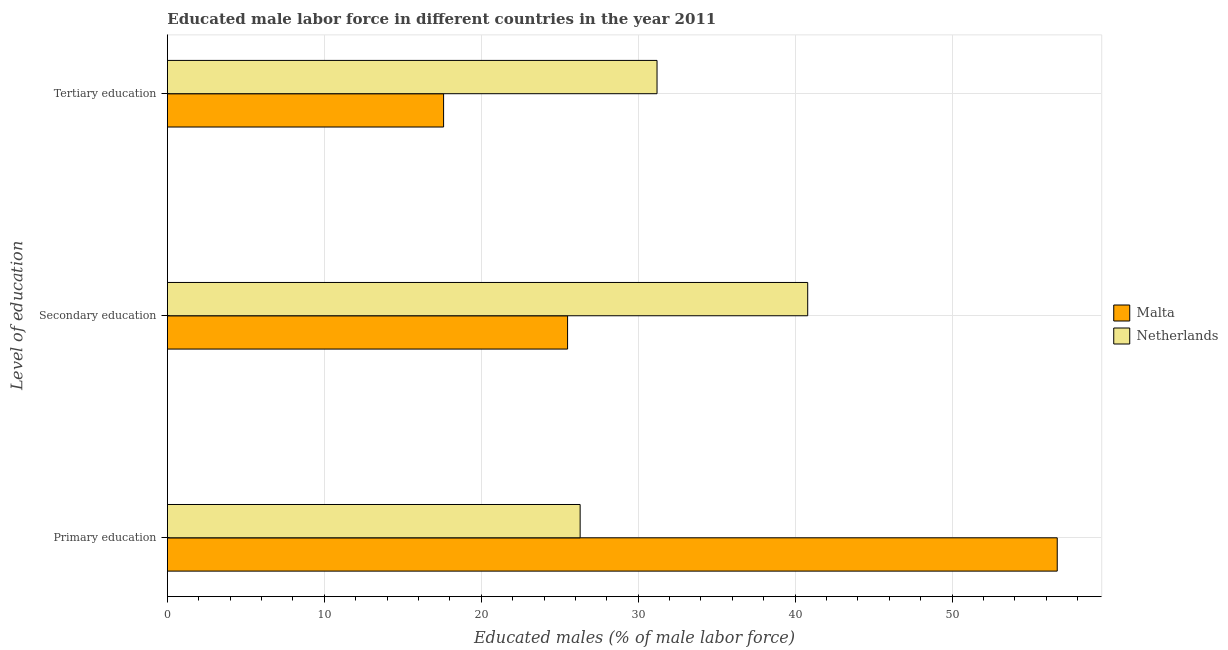Are the number of bars on each tick of the Y-axis equal?
Provide a short and direct response. Yes. How many bars are there on the 3rd tick from the top?
Keep it short and to the point. 2. How many bars are there on the 1st tick from the bottom?
Your answer should be compact. 2. What is the label of the 1st group of bars from the top?
Your answer should be very brief. Tertiary education. What is the percentage of male labor force who received tertiary education in Netherlands?
Give a very brief answer. 31.2. Across all countries, what is the maximum percentage of male labor force who received primary education?
Your answer should be compact. 56.7. Across all countries, what is the minimum percentage of male labor force who received tertiary education?
Provide a short and direct response. 17.6. In which country was the percentage of male labor force who received tertiary education maximum?
Ensure brevity in your answer.  Netherlands. In which country was the percentage of male labor force who received tertiary education minimum?
Your response must be concise. Malta. What is the total percentage of male labor force who received secondary education in the graph?
Offer a terse response. 66.3. What is the difference between the percentage of male labor force who received secondary education in Netherlands and that in Malta?
Keep it short and to the point. 15.3. What is the difference between the percentage of male labor force who received tertiary education in Netherlands and the percentage of male labor force who received secondary education in Malta?
Offer a very short reply. 5.7. What is the average percentage of male labor force who received primary education per country?
Keep it short and to the point. 41.5. What is the difference between the percentage of male labor force who received tertiary education and percentage of male labor force who received secondary education in Netherlands?
Ensure brevity in your answer.  -9.6. What is the ratio of the percentage of male labor force who received tertiary education in Malta to that in Netherlands?
Make the answer very short. 0.56. Is the difference between the percentage of male labor force who received tertiary education in Netherlands and Malta greater than the difference between the percentage of male labor force who received secondary education in Netherlands and Malta?
Make the answer very short. No. What is the difference between the highest and the second highest percentage of male labor force who received secondary education?
Provide a short and direct response. 15.3. What is the difference between the highest and the lowest percentage of male labor force who received tertiary education?
Give a very brief answer. 13.6. In how many countries, is the percentage of male labor force who received secondary education greater than the average percentage of male labor force who received secondary education taken over all countries?
Your response must be concise. 1. What does the 2nd bar from the top in Tertiary education represents?
Make the answer very short. Malta. What does the 1st bar from the bottom in Primary education represents?
Your answer should be very brief. Malta. Is it the case that in every country, the sum of the percentage of male labor force who received primary education and percentage of male labor force who received secondary education is greater than the percentage of male labor force who received tertiary education?
Give a very brief answer. Yes. How many bars are there?
Offer a terse response. 6. Are all the bars in the graph horizontal?
Offer a terse response. Yes. How many countries are there in the graph?
Provide a short and direct response. 2. Does the graph contain grids?
Your answer should be very brief. Yes. How are the legend labels stacked?
Your response must be concise. Vertical. What is the title of the graph?
Offer a terse response. Educated male labor force in different countries in the year 2011. What is the label or title of the X-axis?
Offer a very short reply. Educated males (% of male labor force). What is the label or title of the Y-axis?
Your answer should be very brief. Level of education. What is the Educated males (% of male labor force) of Malta in Primary education?
Offer a terse response. 56.7. What is the Educated males (% of male labor force) of Netherlands in Primary education?
Ensure brevity in your answer.  26.3. What is the Educated males (% of male labor force) of Malta in Secondary education?
Make the answer very short. 25.5. What is the Educated males (% of male labor force) in Netherlands in Secondary education?
Your answer should be compact. 40.8. What is the Educated males (% of male labor force) in Malta in Tertiary education?
Your answer should be very brief. 17.6. What is the Educated males (% of male labor force) of Netherlands in Tertiary education?
Give a very brief answer. 31.2. Across all Level of education, what is the maximum Educated males (% of male labor force) of Malta?
Keep it short and to the point. 56.7. Across all Level of education, what is the maximum Educated males (% of male labor force) in Netherlands?
Ensure brevity in your answer.  40.8. Across all Level of education, what is the minimum Educated males (% of male labor force) in Malta?
Offer a very short reply. 17.6. Across all Level of education, what is the minimum Educated males (% of male labor force) in Netherlands?
Your answer should be compact. 26.3. What is the total Educated males (% of male labor force) in Malta in the graph?
Offer a terse response. 99.8. What is the total Educated males (% of male labor force) of Netherlands in the graph?
Provide a short and direct response. 98.3. What is the difference between the Educated males (% of male labor force) of Malta in Primary education and that in Secondary education?
Offer a terse response. 31.2. What is the difference between the Educated males (% of male labor force) in Netherlands in Primary education and that in Secondary education?
Make the answer very short. -14.5. What is the difference between the Educated males (% of male labor force) of Malta in Primary education and that in Tertiary education?
Your answer should be compact. 39.1. What is the difference between the Educated males (% of male labor force) in Netherlands in Primary education and that in Tertiary education?
Your answer should be compact. -4.9. What is the difference between the Educated males (% of male labor force) in Malta in Secondary education and that in Tertiary education?
Your answer should be compact. 7.9. What is the difference between the Educated males (% of male labor force) in Netherlands in Secondary education and that in Tertiary education?
Provide a succinct answer. 9.6. What is the average Educated males (% of male labor force) of Malta per Level of education?
Ensure brevity in your answer.  33.27. What is the average Educated males (% of male labor force) in Netherlands per Level of education?
Keep it short and to the point. 32.77. What is the difference between the Educated males (% of male labor force) in Malta and Educated males (% of male labor force) in Netherlands in Primary education?
Your answer should be compact. 30.4. What is the difference between the Educated males (% of male labor force) in Malta and Educated males (% of male labor force) in Netherlands in Secondary education?
Offer a very short reply. -15.3. What is the difference between the Educated males (% of male labor force) in Malta and Educated males (% of male labor force) in Netherlands in Tertiary education?
Keep it short and to the point. -13.6. What is the ratio of the Educated males (% of male labor force) in Malta in Primary education to that in Secondary education?
Offer a very short reply. 2.22. What is the ratio of the Educated males (% of male labor force) of Netherlands in Primary education to that in Secondary education?
Ensure brevity in your answer.  0.64. What is the ratio of the Educated males (% of male labor force) in Malta in Primary education to that in Tertiary education?
Ensure brevity in your answer.  3.22. What is the ratio of the Educated males (% of male labor force) in Netherlands in Primary education to that in Tertiary education?
Your response must be concise. 0.84. What is the ratio of the Educated males (% of male labor force) in Malta in Secondary education to that in Tertiary education?
Make the answer very short. 1.45. What is the ratio of the Educated males (% of male labor force) in Netherlands in Secondary education to that in Tertiary education?
Your answer should be very brief. 1.31. What is the difference between the highest and the second highest Educated males (% of male labor force) of Malta?
Ensure brevity in your answer.  31.2. What is the difference between the highest and the lowest Educated males (% of male labor force) in Malta?
Keep it short and to the point. 39.1. What is the difference between the highest and the lowest Educated males (% of male labor force) in Netherlands?
Make the answer very short. 14.5. 